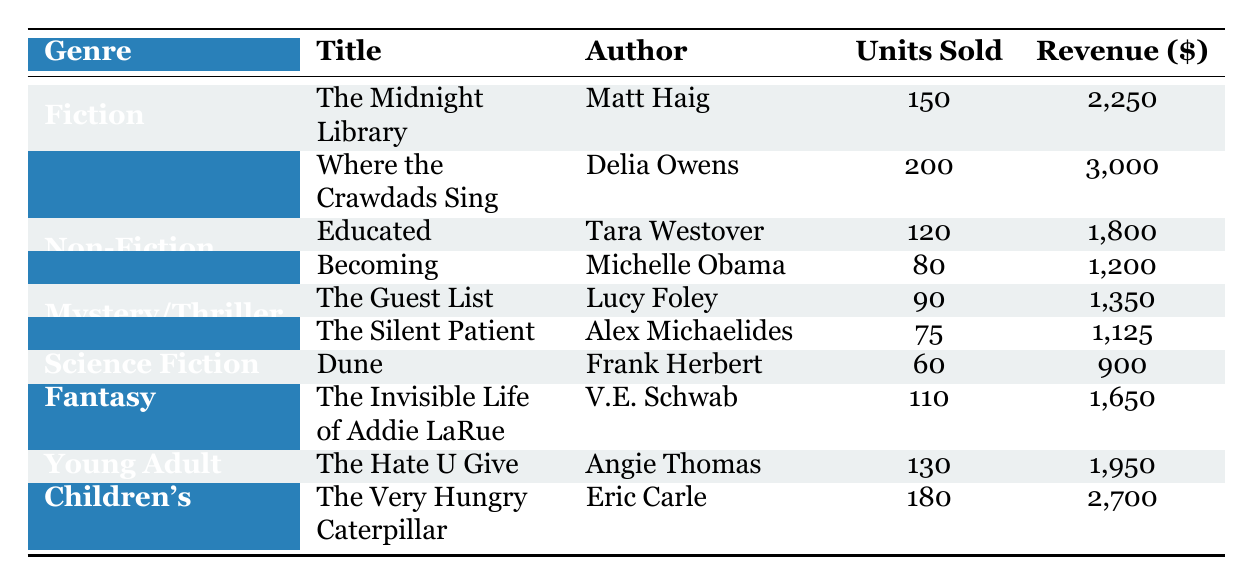What is the total revenue generated by the Fiction genre? To find the total revenue for the Fiction genre, we need to sum the revenue values of all the Fiction titles. The titles are "The Midnight Library" generating $2,250 and "Where the Crawdads Sing" generating $3,000. Thus, total revenue = 2,250 + 3,000 = 5,250.
Answer: 5,250 How many units of "Dune" were sold? The table directly lists the units sold for "Dune" as 60.
Answer: 60 Is "Becoming" a best-seller in the Non-Fiction category based on units sold? To determine if "Becoming" is a best-seller in its category, we compare its units sold (80) against "Educated" (120). Since 80 is less than 120, "Becoming" is not the best-seller in Non-Fiction.
Answer: No Which genre had the highest number of total units sold? First, we will calculate the total units sold for each genre: For Fiction: 150 + 200 = 350, Non-Fiction: 120 + 80 = 200, Mystery/Thriller: 90 + 75 = 165, Science Fiction: 60 (only one title), Fantasy: 110, Young Adult: 130, and Children’s: 180. Comparing these totals, Fiction with 350 units sold has the highest.
Answer: Fiction What is the average revenue for the Mystery/Thriller genre? The revenue for Mystery/Thriller titles is $1,350 for "The Guest List" and $1,125 for "The Silent Patient." The total revenue is 1,350 + 1,125 = 2,475. There are 2 titles in this genre. Average revenue = 2,475 / 2 = 1,237.50.
Answer: 1,237.50 Does the Children’s genre have higher total revenue than the Fantasy genre? The total revenue for the Children's genre is $2,700 (from "The Very Hungry Caterpillar"), and for the Fantasy genre, it’s $1,650 (from "The Invisible Life of Addie LaRue"). Since 2,700 is greater than 1,650, the Children's genre does have higher revenue.
Answer: Yes Which author sold the most units combined between their titles? "Delia Owens" includes "Where the Crawdads Sing" with 200 units and "Michelle Obama" has "Becoming" with 80 units. Other authors sold: Tara Westover (120), Matt Haig (150), Lucy Foley (90), Alex Michaelides (75), Frank Herbert (60), V.E. Schwab (110), and Angie Thomas (130). Delia Owens has the highest with 200 units sold.
Answer: Delia Owens What is the total number of units sold across all genres? To find this, we sum up all the units sold: Fiction (350) + Non-Fiction (200) + Mystery/Thriller (165) + Science Fiction (60) + Fantasy (110) + Young Adult (130) + Children's (180). Adding, we get 350 + 200 + 165 + 60 + 110 + 130 + 180 = 1,195.
Answer: 1,195 